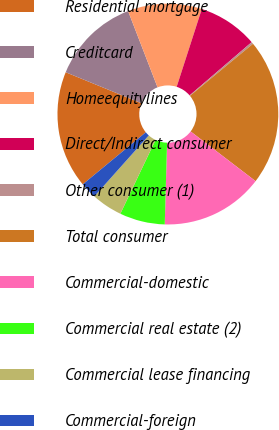<chart> <loc_0><loc_0><loc_500><loc_500><pie_chart><fcel>Residential mortgage<fcel>Creditcard<fcel>Homeequitylines<fcel>Direct/Indirect consumer<fcel>Other consumer (1)<fcel>Total consumer<fcel>Commercial-domestic<fcel>Commercial real estate (2)<fcel>Commercial lease financing<fcel>Commercial-foreign<nl><fcel>17.17%<fcel>12.95%<fcel>10.84%<fcel>8.74%<fcel>0.3%<fcel>21.38%<fcel>15.06%<fcel>6.63%<fcel>4.52%<fcel>2.41%<nl></chart> 